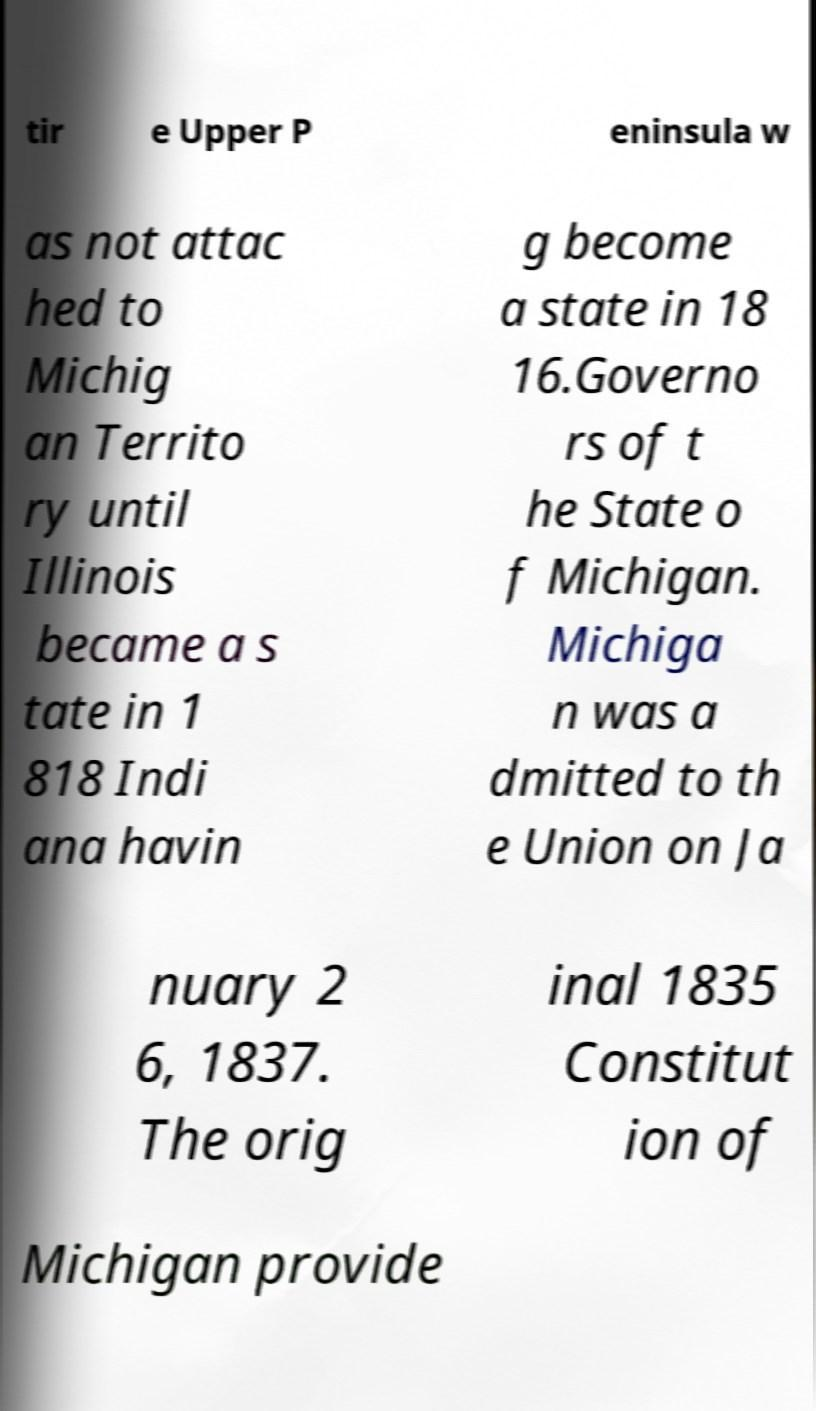Could you assist in decoding the text presented in this image and type it out clearly? tir e Upper P eninsula w as not attac hed to Michig an Territo ry until Illinois became a s tate in 1 818 Indi ana havin g become a state in 18 16.Governo rs of t he State o f Michigan. Michiga n was a dmitted to th e Union on Ja nuary 2 6, 1837. The orig inal 1835 Constitut ion of Michigan provide 